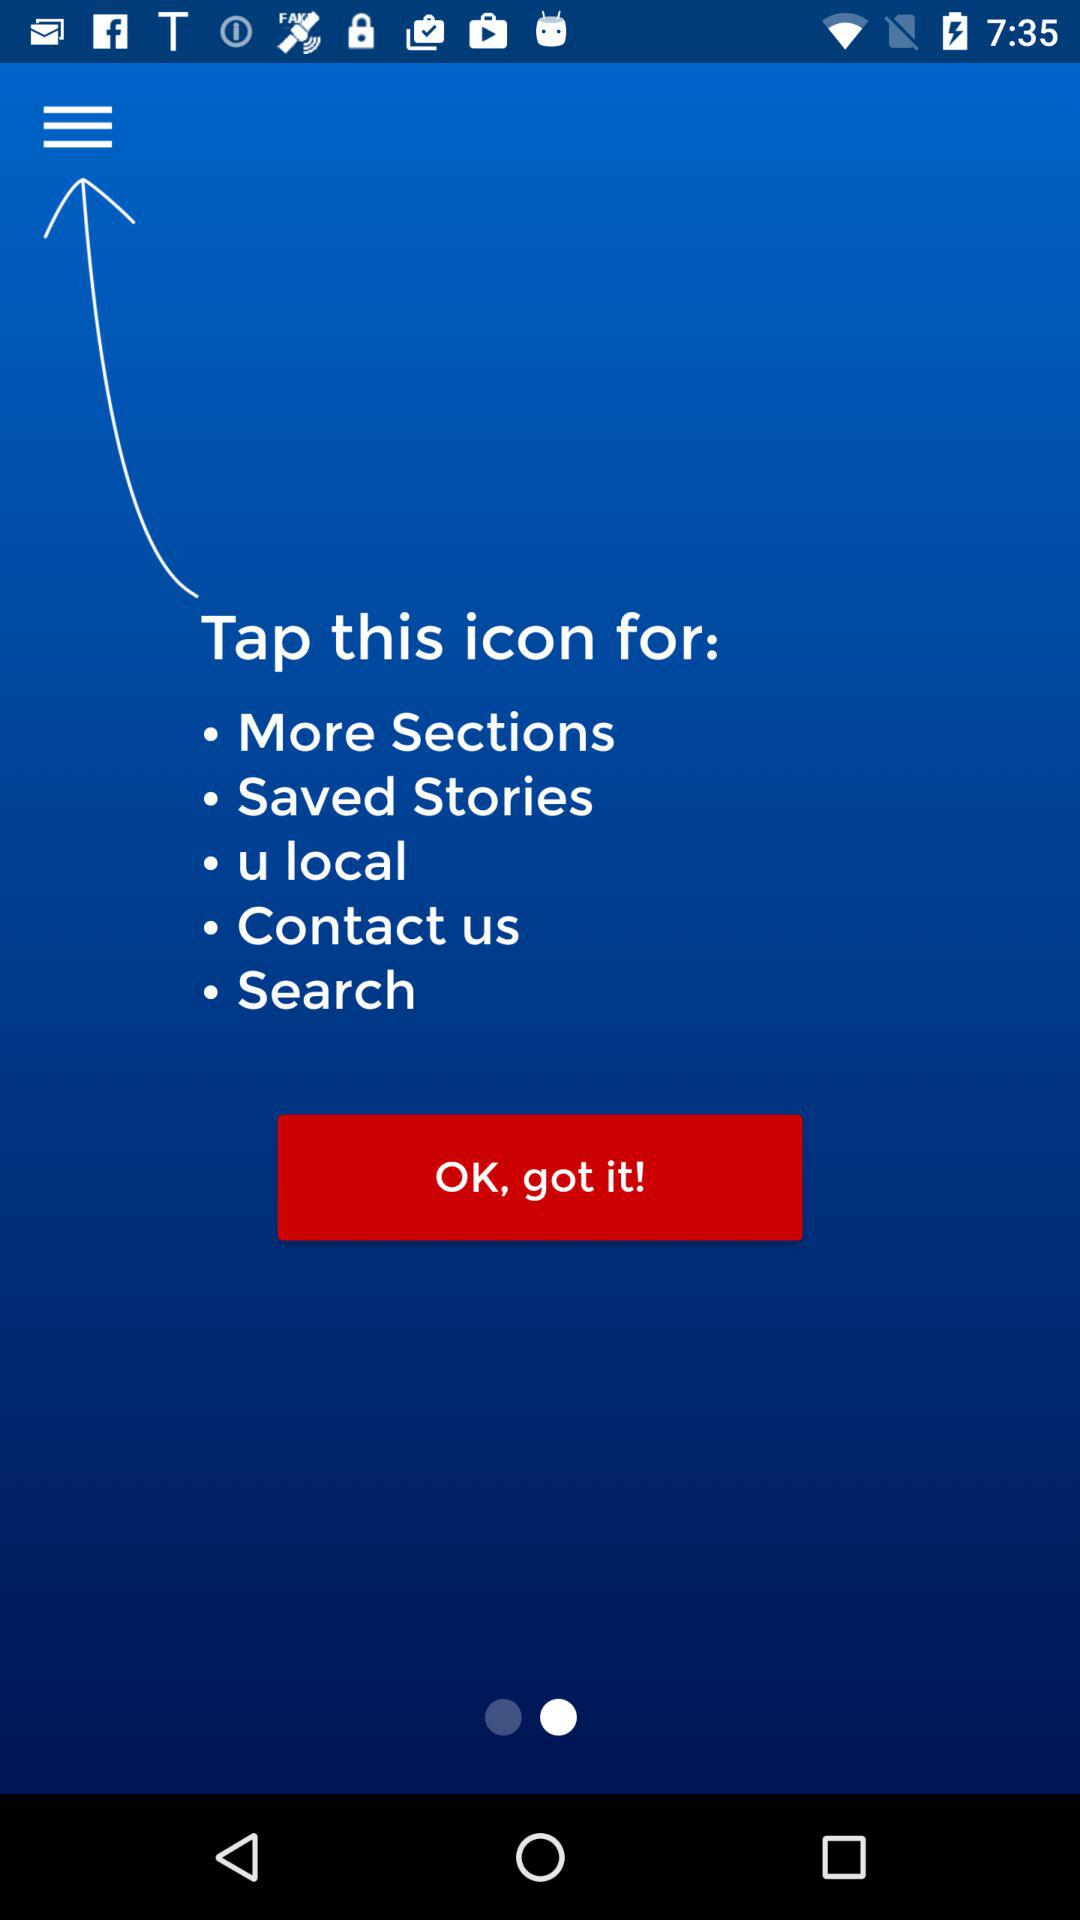How many sections are there in the menu?
Answer the question using a single word or phrase. 5 